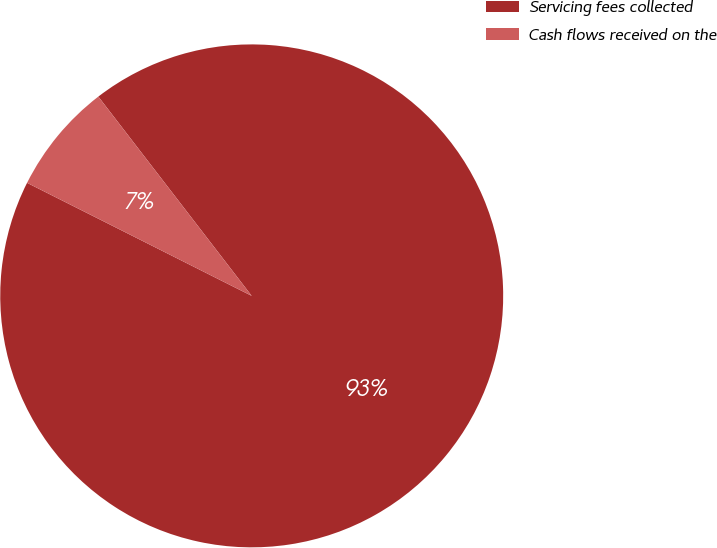<chart> <loc_0><loc_0><loc_500><loc_500><pie_chart><fcel>Servicing fees collected<fcel>Cash flows received on the<nl><fcel>92.86%<fcel>7.14%<nl></chart> 